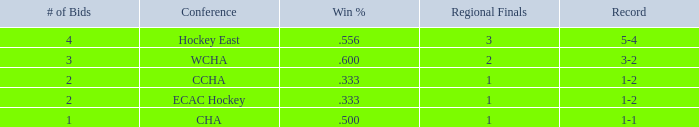What is the average Regional Finals score when the record is 3-2 and there are more than 3 bids? None. 